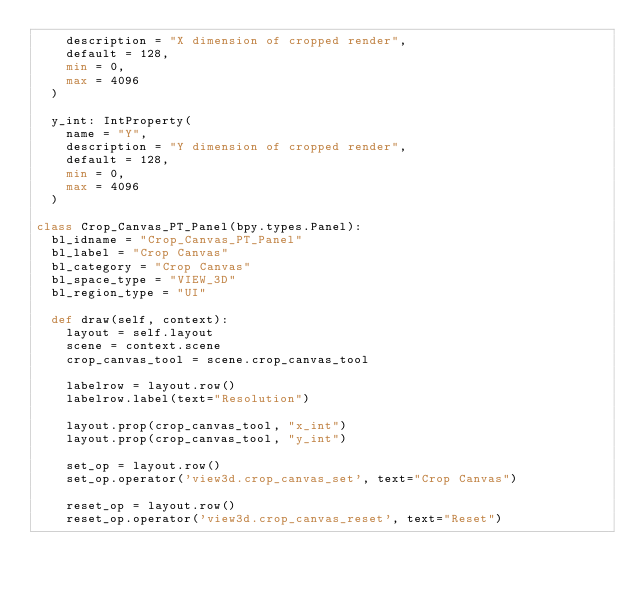Convert code to text. <code><loc_0><loc_0><loc_500><loc_500><_Python_>    description = "X dimension of cropped render",
    default = 128,
    min = 0,
    max = 4096
  )

  y_int: IntProperty(
    name = "Y",
    description = "Y dimension of cropped render",
    default = 128,
    min = 0,
    max = 4096
  )

class Crop_Canvas_PT_Panel(bpy.types.Panel):
  bl_idname = "Crop_Canvas_PT_Panel"
  bl_label = "Crop Canvas"
  bl_category = "Crop Canvas"
  bl_space_type = "VIEW_3D"
  bl_region_type = "UI"

  def draw(self, context):
    layout = self.layout
    scene = context.scene
    crop_canvas_tool = scene.crop_canvas_tool

    labelrow = layout.row()
    labelrow.label(text="Resolution")

    layout.prop(crop_canvas_tool, "x_int")
    layout.prop(crop_canvas_tool, "y_int")

    set_op = layout.row()
    set_op.operator('view3d.crop_canvas_set', text="Crop Canvas")

    reset_op = layout.row()
    reset_op.operator('view3d.crop_canvas_reset', text="Reset")</code> 